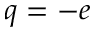Convert formula to latex. <formula><loc_0><loc_0><loc_500><loc_500>q = - e</formula> 